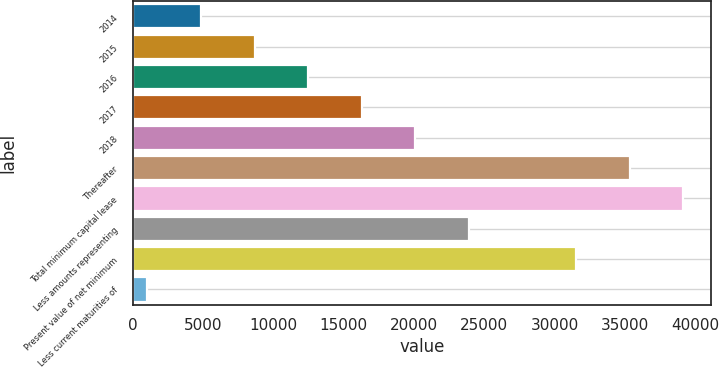Convert chart. <chart><loc_0><loc_0><loc_500><loc_500><bar_chart><fcel>2014<fcel>2015<fcel>2016<fcel>2017<fcel>2018<fcel>Thereafter<fcel>Total minimum capital lease<fcel>Less amounts representing<fcel>Present value of net minimum<fcel>Less current maturities of<nl><fcel>4841.4<fcel>8652.8<fcel>12464.2<fcel>16275.6<fcel>20087<fcel>35332.6<fcel>39144<fcel>23898.4<fcel>31521.2<fcel>1030<nl></chart> 